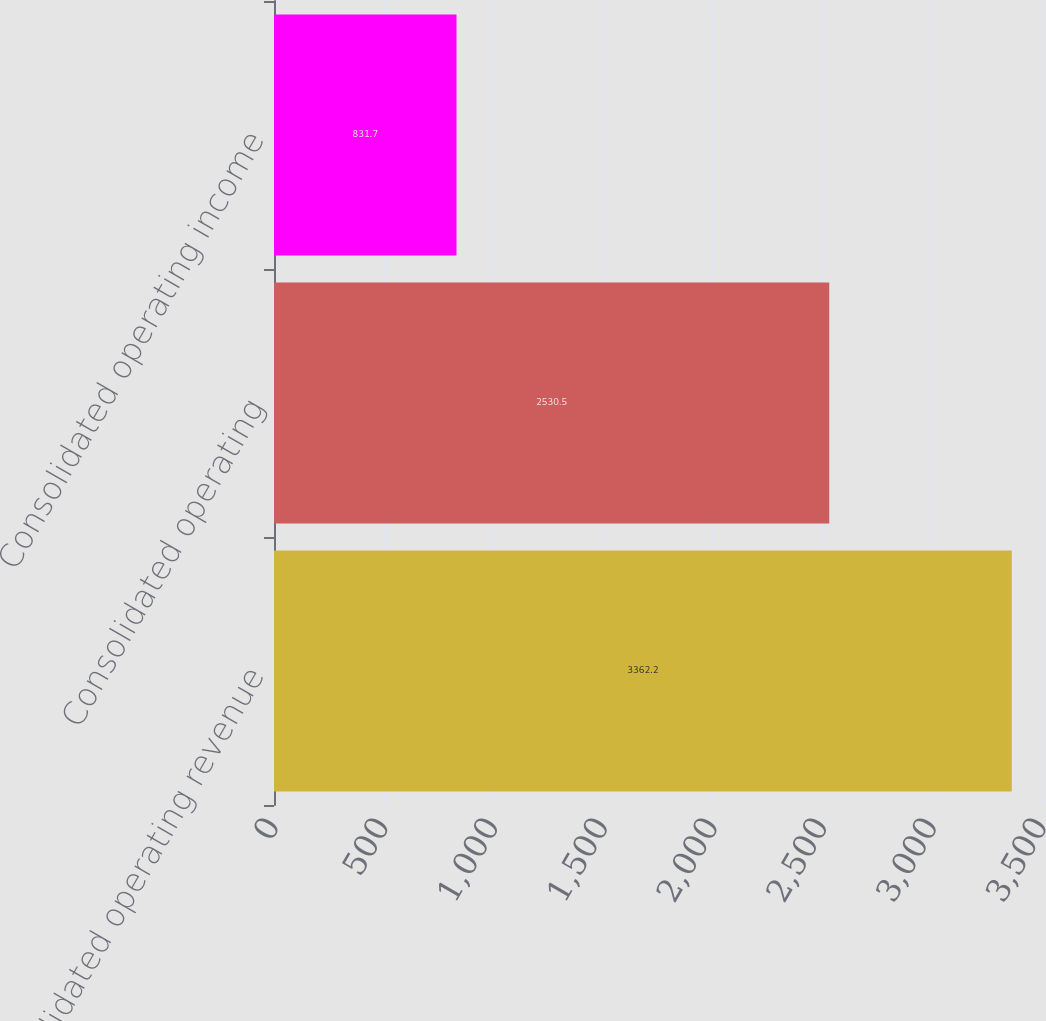Convert chart. <chart><loc_0><loc_0><loc_500><loc_500><bar_chart><fcel>Consolidated operating revenue<fcel>Consolidated operating<fcel>Consolidated operating income<nl><fcel>3362.2<fcel>2530.5<fcel>831.7<nl></chart> 